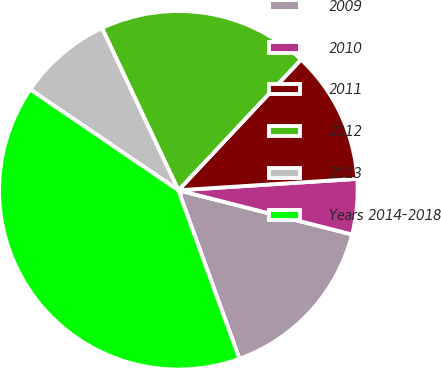Convert chart to OTSL. <chart><loc_0><loc_0><loc_500><loc_500><pie_chart><fcel>2009<fcel>2010<fcel>2011<fcel>2012<fcel>2013<fcel>Years 2014-2018<nl><fcel>15.5%<fcel>4.98%<fcel>11.99%<fcel>19.0%<fcel>8.49%<fcel>40.04%<nl></chart> 